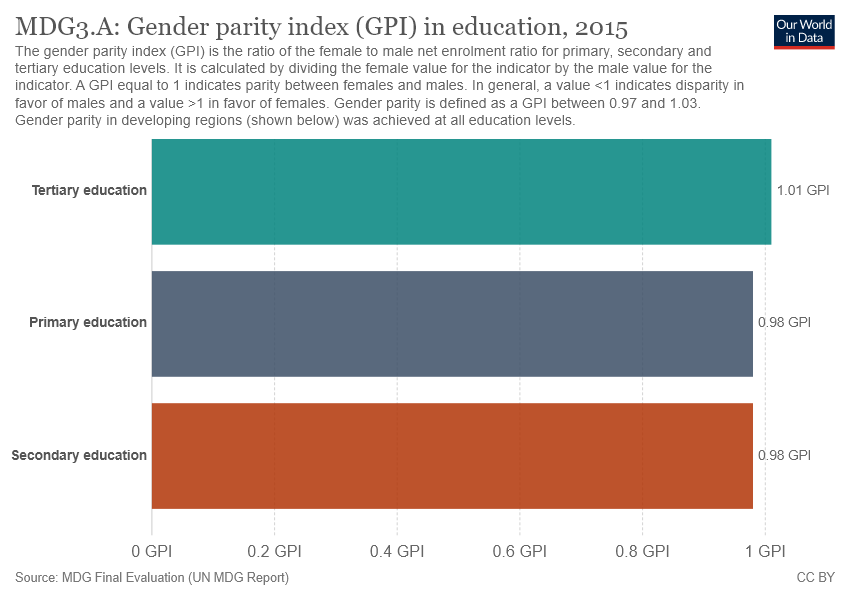Outline some significant characteristics in this image. Out of the number of bars that have a value of 0.98, there are two bars. The value of secondary education is 0.98. 